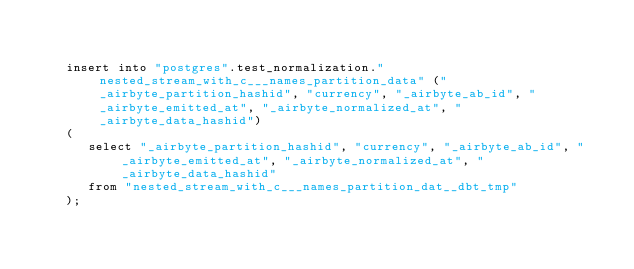<code> <loc_0><loc_0><loc_500><loc_500><_SQL_>      

    insert into "postgres".test_normalization."nested_stream_with_c___names_partition_data" ("_airbyte_partition_hashid", "currency", "_airbyte_ab_id", "_airbyte_emitted_at", "_airbyte_normalized_at", "_airbyte_data_hashid")
    (
       select "_airbyte_partition_hashid", "currency", "_airbyte_ab_id", "_airbyte_emitted_at", "_airbyte_normalized_at", "_airbyte_data_hashid"
       from "nested_stream_with_c___names_partition_dat__dbt_tmp"
    );
  </code> 